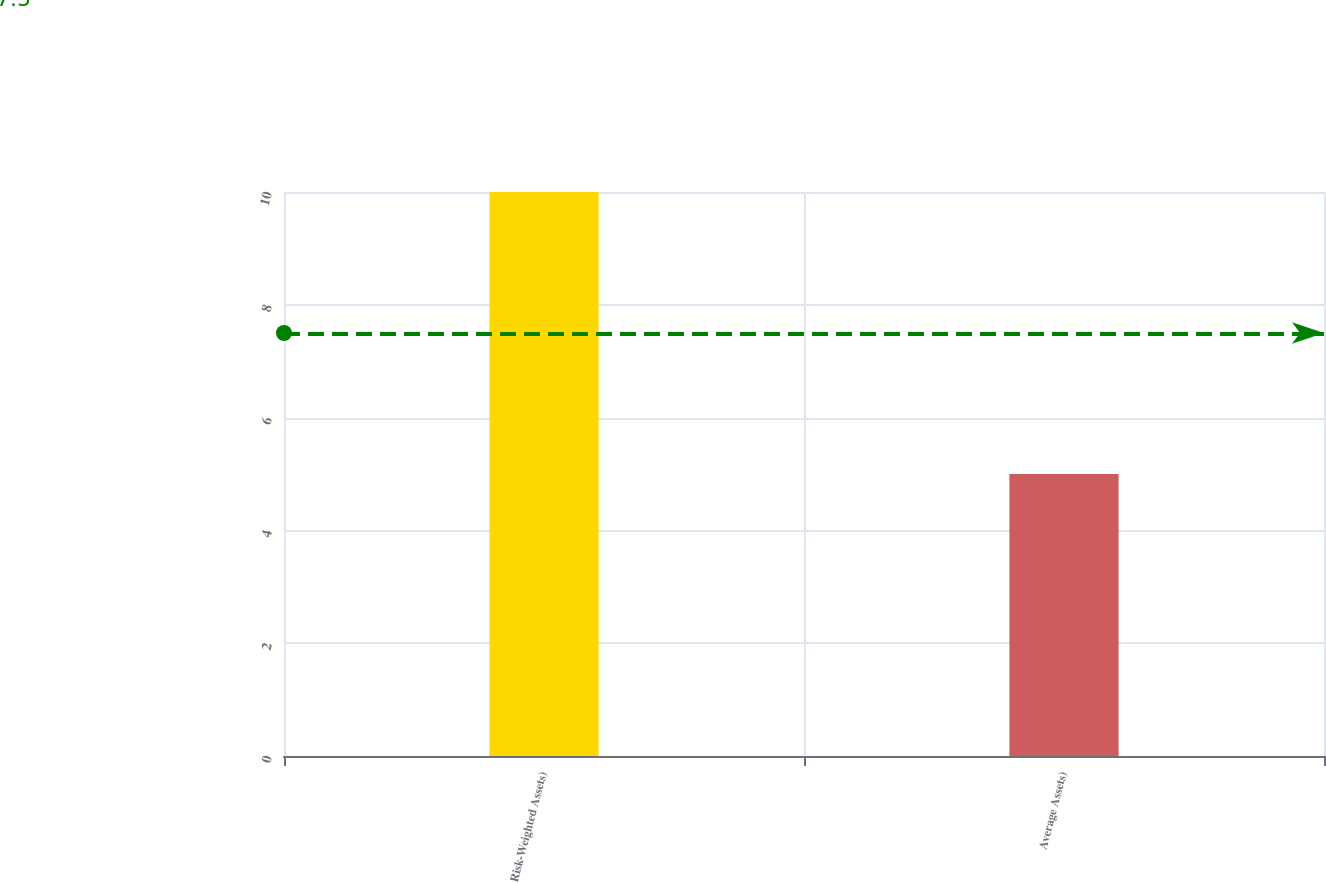Convert chart. <chart><loc_0><loc_0><loc_500><loc_500><bar_chart><fcel>Risk-Weighted Assets)<fcel>Average Assets)<nl><fcel>10<fcel>5<nl></chart> 